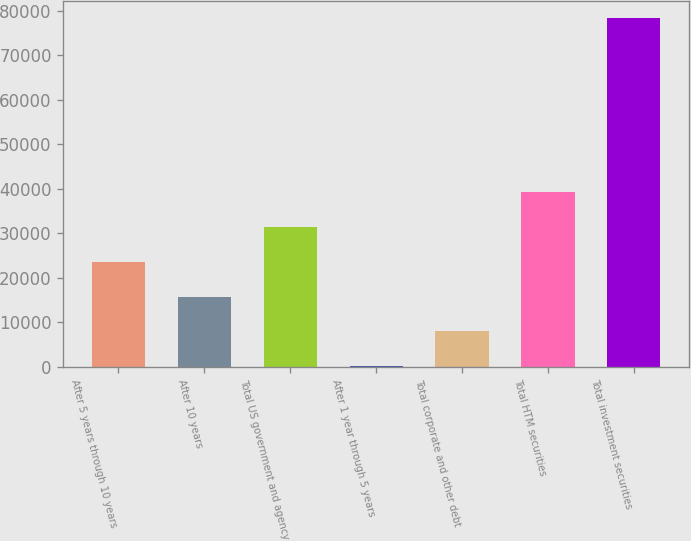<chart> <loc_0><loc_0><loc_500><loc_500><bar_chart><fcel>After 5 years through 10 years<fcel>After 10 years<fcel>Total US government and agency<fcel>After 1 year through 5 years<fcel>Total corporate and other debt<fcel>Total HTM securities<fcel>Total investment securities<nl><fcel>23551.7<fcel>15732.8<fcel>31370.6<fcel>95<fcel>7913.9<fcel>39189.5<fcel>78284<nl></chart> 